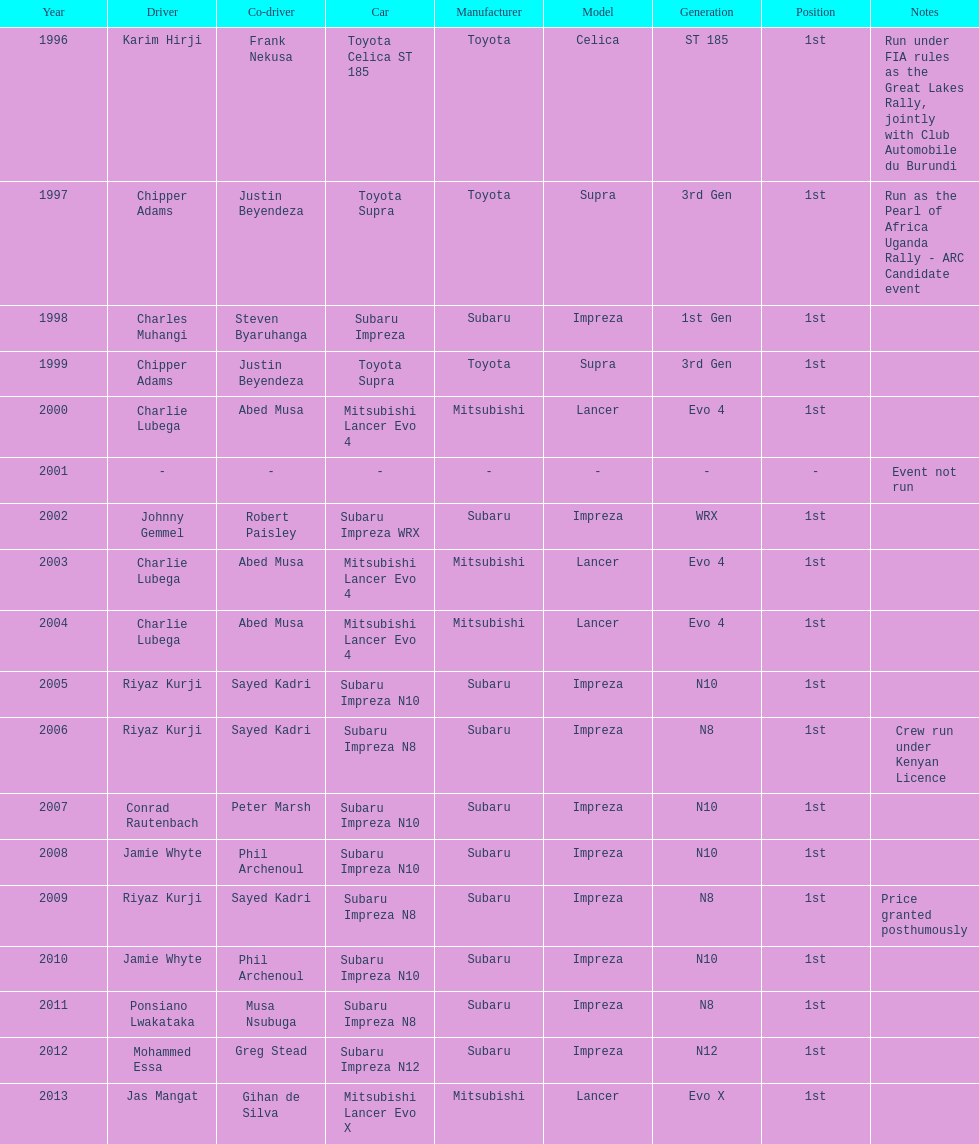How many drivers won at least twice? 4. 